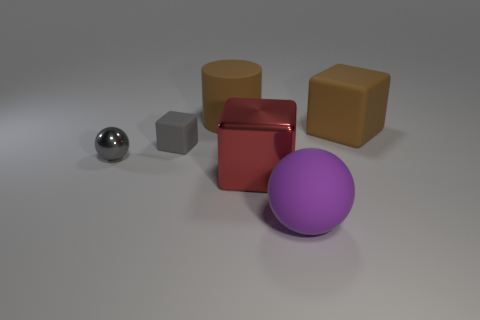Add 1 green shiny spheres. How many objects exist? 7 Subtract all spheres. How many objects are left? 4 Add 3 small metal balls. How many small metal balls are left? 4 Add 5 large red shiny objects. How many large red shiny objects exist? 6 Subtract 0 yellow cubes. How many objects are left? 6 Subtract all blue rubber cylinders. Subtract all large metal cubes. How many objects are left? 5 